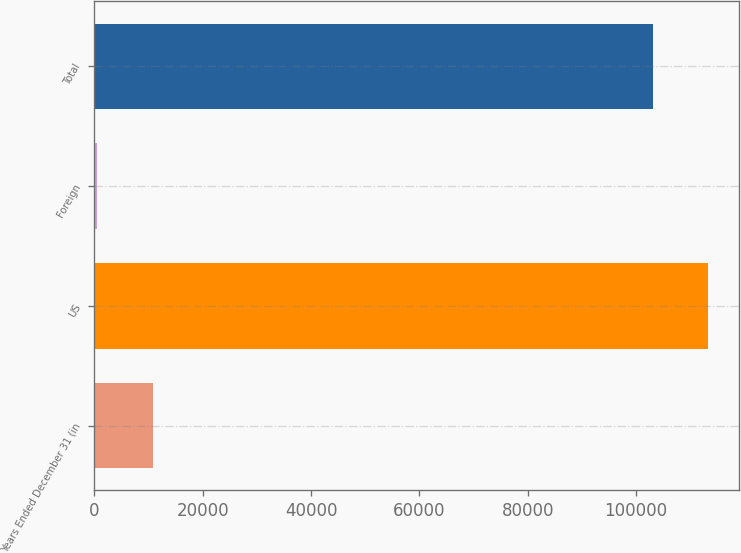<chart> <loc_0><loc_0><loc_500><loc_500><bar_chart><fcel>Years Ended December 31 (in<fcel>US<fcel>Foreign<fcel>Total<nl><fcel>10825.9<fcel>113332<fcel>523<fcel>103029<nl></chart> 